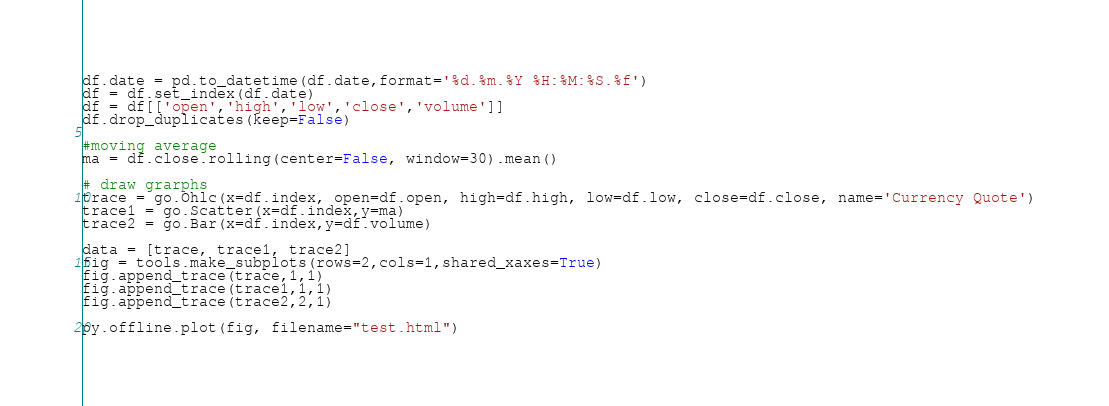<code> <loc_0><loc_0><loc_500><loc_500><_Python_>df.date = pd.to_datetime(df.date,format='%d.%m.%Y %H:%M:%S.%f')
df = df.set_index(df.date)
df = df[['open','high','low','close','volume']]
df.drop_duplicates(keep=False)

#moving average
ma = df.close.rolling(center=False, window=30).mean()

# draw grarphs
trace = go.Ohlc(x=df.index, open=df.open, high=df.high, low=df.low, close=df.close, name='Currency Quote')
trace1 = go.Scatter(x=df.index,y=ma)
trace2 = go.Bar(x=df.index,y=df.volume)

data = [trace, trace1, trace2]
fig = tools.make_subplots(rows=2,cols=1,shared_xaxes=True)
fig.append_trace(trace,1,1)
fig.append_trace(trace1,1,1)
fig.append_trace(trace2,2,1)

py.offline.plot(fig, filename="test.html")</code> 